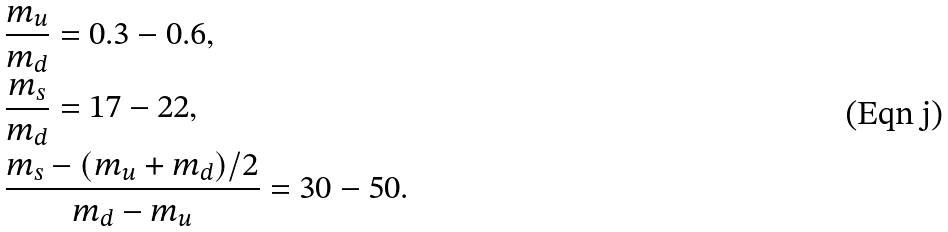Convert formula to latex. <formula><loc_0><loc_0><loc_500><loc_500>& \frac { m _ { u } } { m _ { d } } = 0 . 3 - 0 . 6 , \\ & \frac { m _ { s } } { m _ { d } } = 1 7 - 2 2 , \\ & \frac { m _ { s } - ( m _ { u } + m _ { d } ) / 2 } { m _ { d } - m _ { u } } = 3 0 - 5 0 .</formula> 